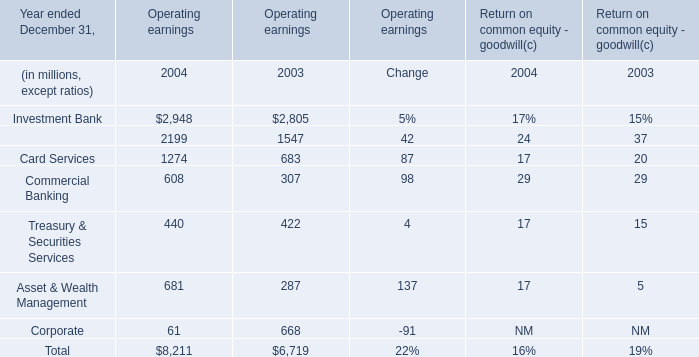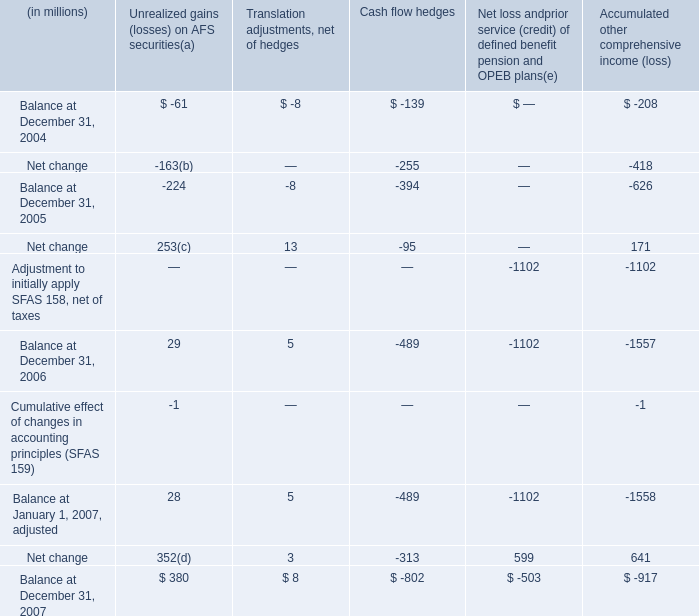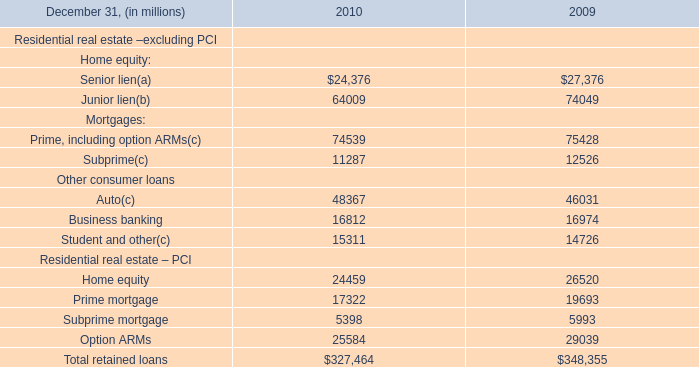What was the total amount of the Commercial Banking in the years where Card Services greater than 0? (in million) 
Computations: (608 + 307)
Answer: 915.0. 